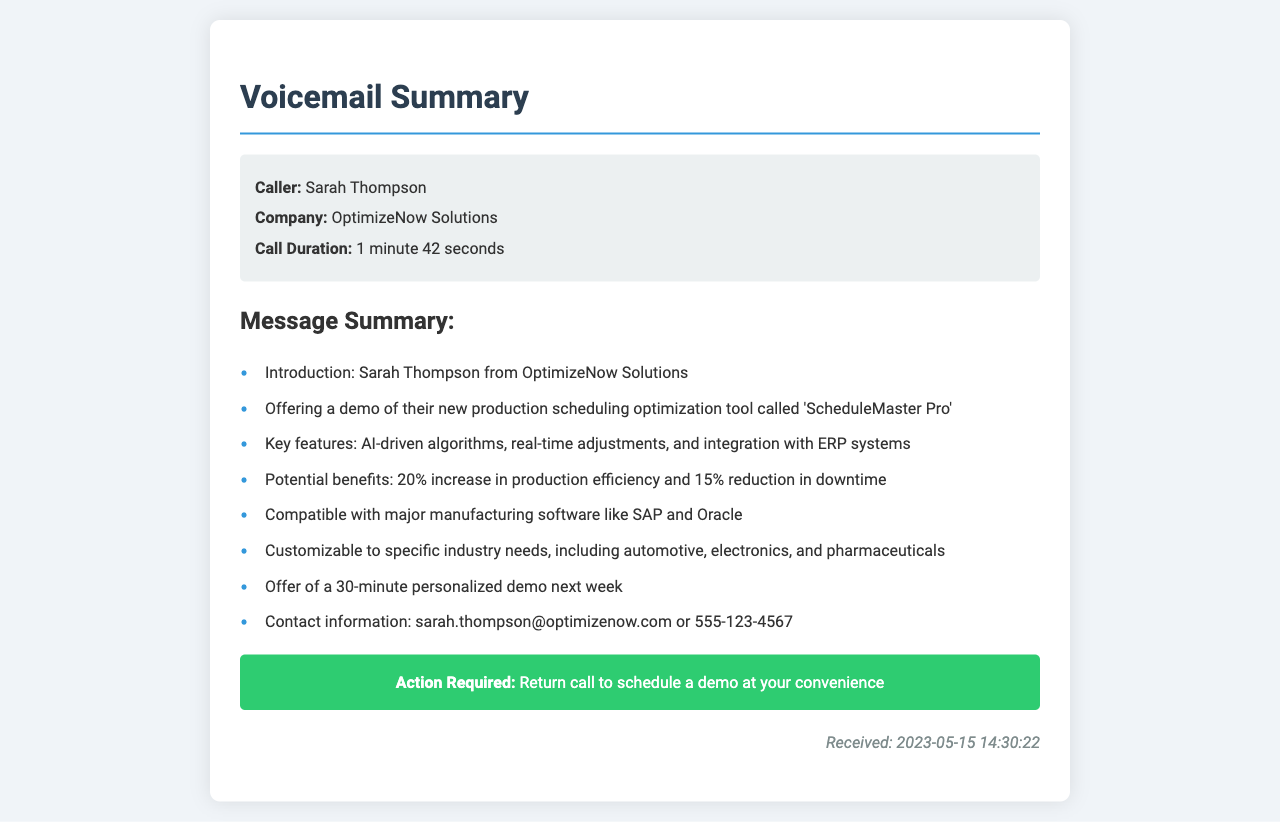What is the name of the caller? The document states that the caller is Sarah Thompson.
Answer: Sarah Thompson What company is associated with the caller? The voicemail identifies the caller's company as OptimizeNow Solutions.
Answer: OptimizeNow Solutions What is the duration of the call? The call duration is provided in the document as 1 minute 42 seconds.
Answer: 1 minute 42 seconds What is the name of the production scheduling tool? The document specifies that the tool being offered is called 'ScheduleMaster Pro'.
Answer: ScheduleMaster Pro What percentage increase in production efficiency is mentioned? The voicemail suggests a 20% increase in production efficiency.
Answer: 20% What kind of demo is being offered? The document mentions a 30-minute personalized demo.
Answer: 30-minute personalized demo Which major manufacturing software is compatible with the tool? The voicemail lists SAP and Oracle as compatible software systems.
Answer: SAP and Oracle What are the potential benefits mentioned? The voicemail outlines a 20% increase in production efficiency and a 15% reduction in downtime.
Answer: 20% increase in production efficiency and 15% reduction in downtime What is the contact number provided for follow-up? The voicemail provides a contact number: 555-123-4567.
Answer: 555-123-4567 